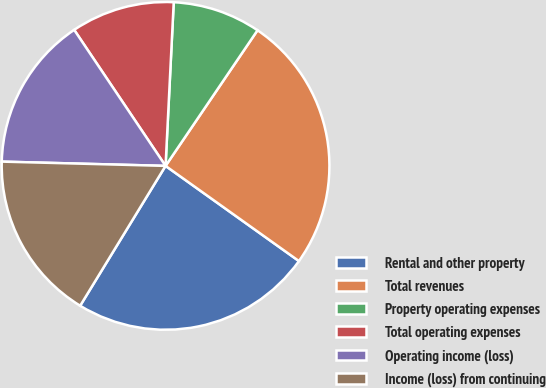<chart> <loc_0><loc_0><loc_500><loc_500><pie_chart><fcel>Rental and other property<fcel>Total revenues<fcel>Property operating expenses<fcel>Total operating expenses<fcel>Operating income (loss)<fcel>Income (loss) from continuing<nl><fcel>23.86%<fcel>25.38%<fcel>8.69%<fcel>10.21%<fcel>15.17%<fcel>16.69%<nl></chart> 